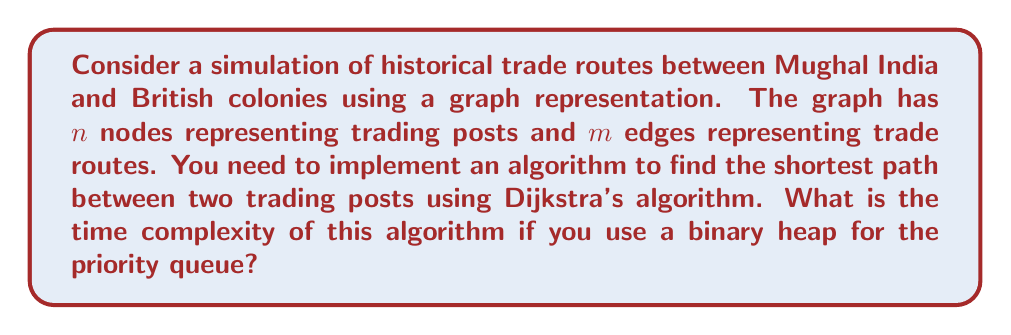Can you answer this question? To analyze the time complexity of Dijkstra's algorithm with a binary heap implementation, we need to consider the following steps:

1. Initialization: 
   - Creating the priority queue: $O(n)$
   - Setting initial distances: $O(n)$

2. Main loop:
   - Extracting the minimum element from the heap: $O(\log n)$
   - This operation is performed $n$ times: $O(n \log n)$

3. Relaxation step:
   - For each node, we potentially update its neighbors
   - Total number of edge relaxations: $O(m)$
   - Each relaxation involves a decrease-key operation on the heap: $O(\log n)$
   - Total cost of relaxations: $O(m \log n)$

Combining these steps:

$$T(n, m) = O(n) + O(n \log n) + O(m \log n)$$

Simplifying:

$$T(n, m) = O((n + m) \log n)$$

For a connected graph, we know that $m \geq n - 1$. Therefore, $m + n = O(m)$. 

Thus, the final time complexity can be expressed as:

$$T(n, m) = O(m \log n)$$

This time complexity reflects the efficiency of using Dijkstra's algorithm with a binary heap to simulate and analyze historical trade routes between Mughal India and British colonies.
Answer: $O(m \log n)$, where $m$ is the number of edges and $n$ is the number of nodes in the graph representing trading posts and routes. 